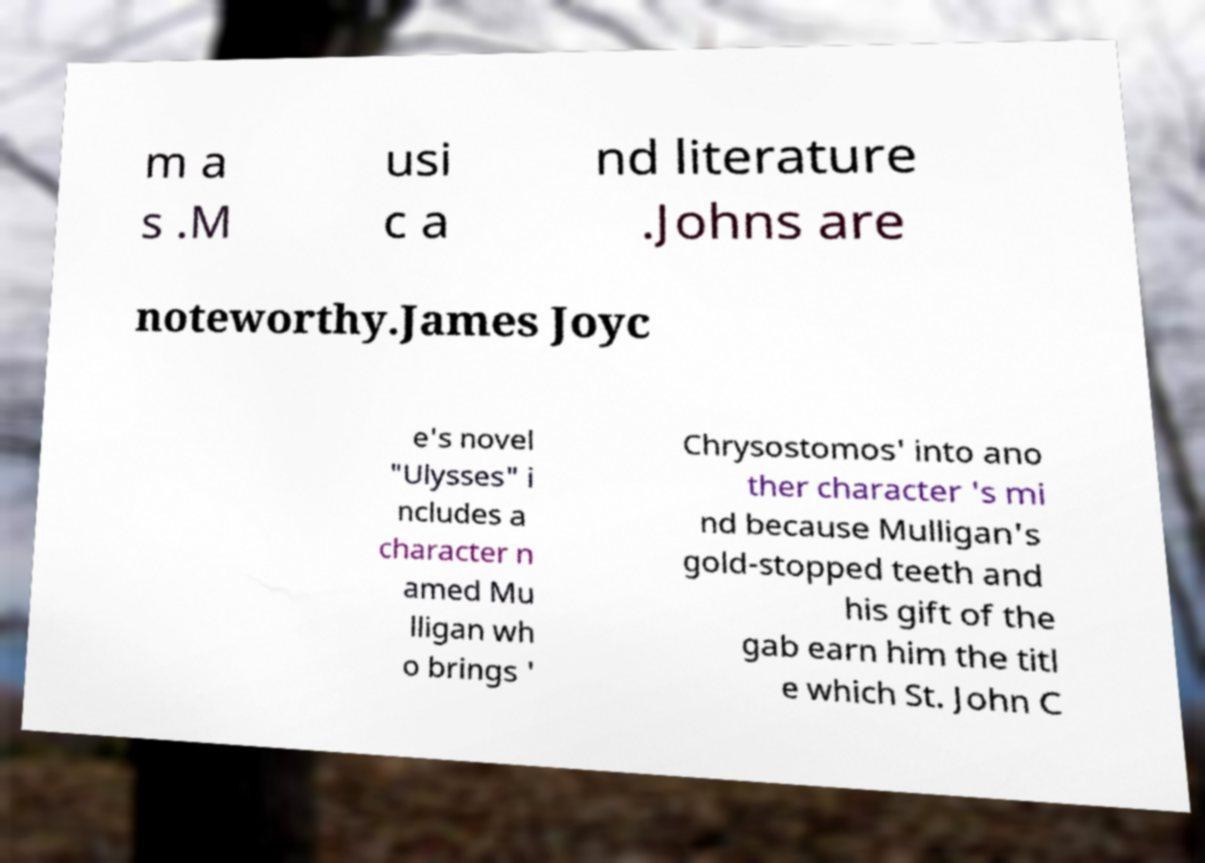Please read and relay the text visible in this image. What does it say? m a s .M usi c a nd literature .Johns are noteworthy.James Joyc e's novel "Ulysses" i ncludes a character n amed Mu lligan wh o brings ' Chrysostomos' into ano ther character 's mi nd because Mulligan's gold-stopped teeth and his gift of the gab earn him the titl e which St. John C 